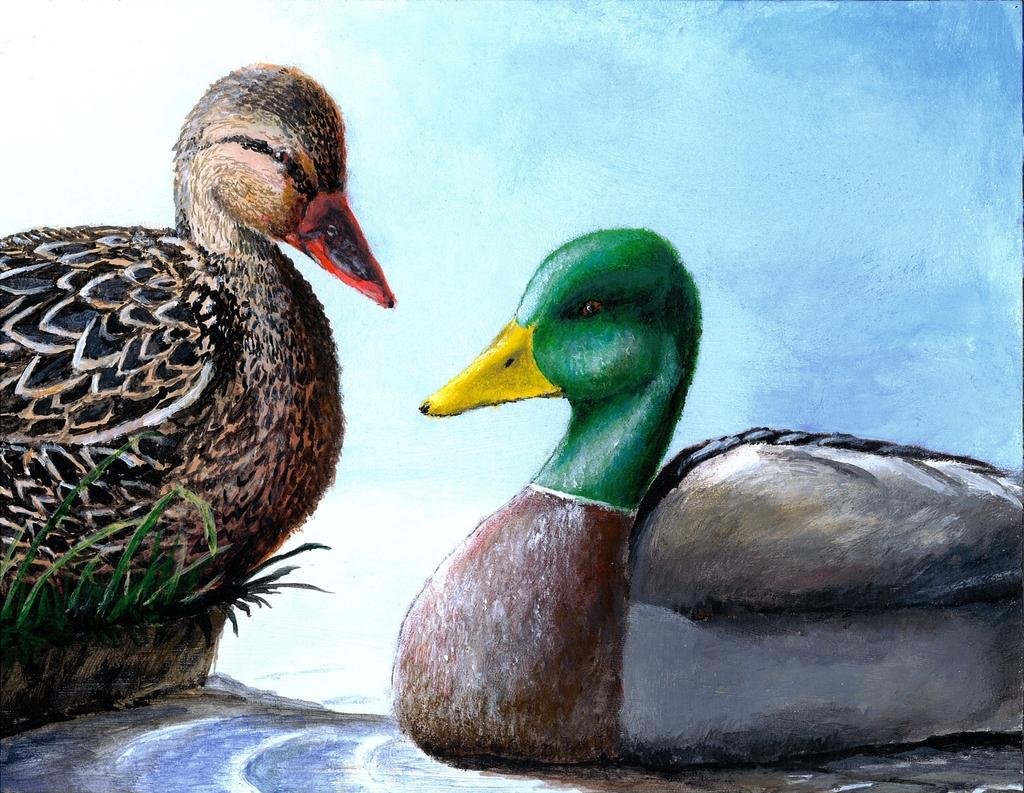What type of artwork is depicted in the image? The image is a painting. What is the main subject of the painting? There are ducks in the center of the painting. What type of environment is depicted in the painting? There is grass depicted in the painting. Where is the shelf located in the painting? There is no shelf present in the painting; it features ducks and grass. What type of transportation device can be seen in the painting? There is no transportation device, such as a train, present in the painting. 